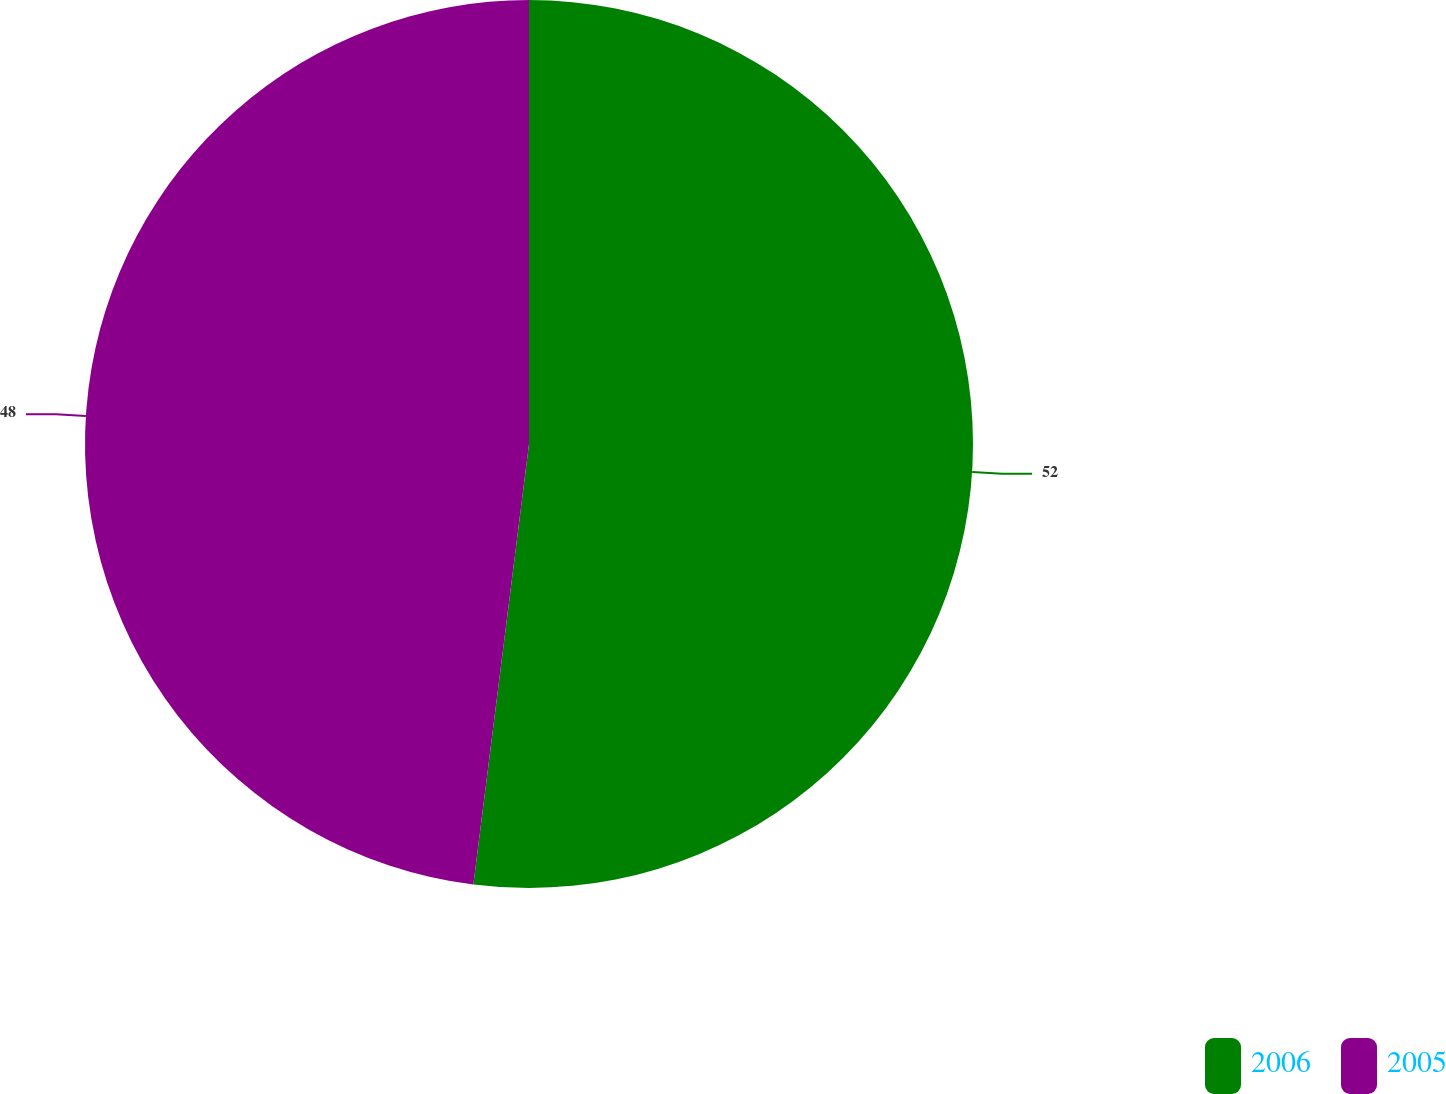<chart> <loc_0><loc_0><loc_500><loc_500><pie_chart><fcel>2006<fcel>2005<nl><fcel>52.0%<fcel>48.0%<nl></chart> 